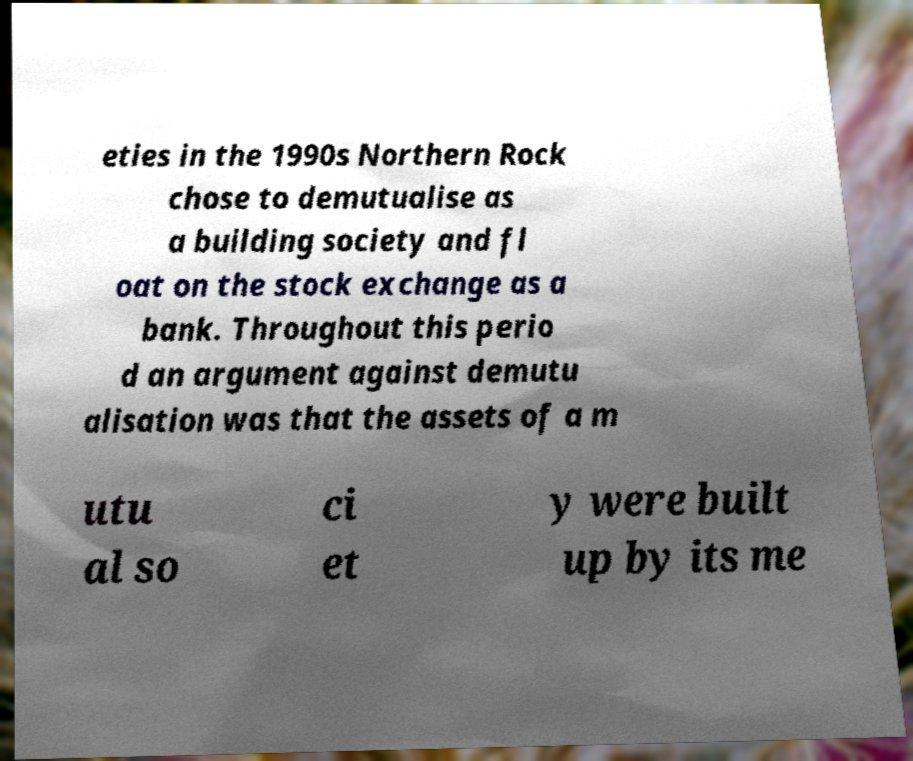Please read and relay the text visible in this image. What does it say? eties in the 1990s Northern Rock chose to demutualise as a building society and fl oat on the stock exchange as a bank. Throughout this perio d an argument against demutu alisation was that the assets of a m utu al so ci et y were built up by its me 